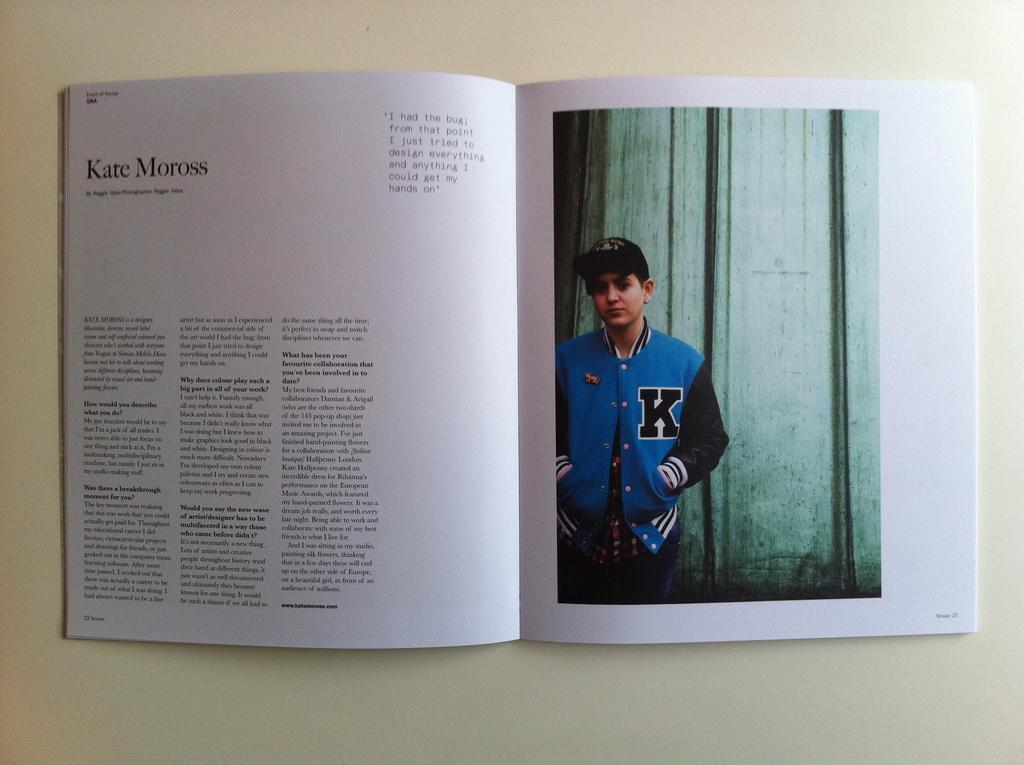<image>
Write a terse but informative summary of the picture. A magazine is open to a spread, the title Kate Moross and copy on the left and a image of a boy on the right page. 